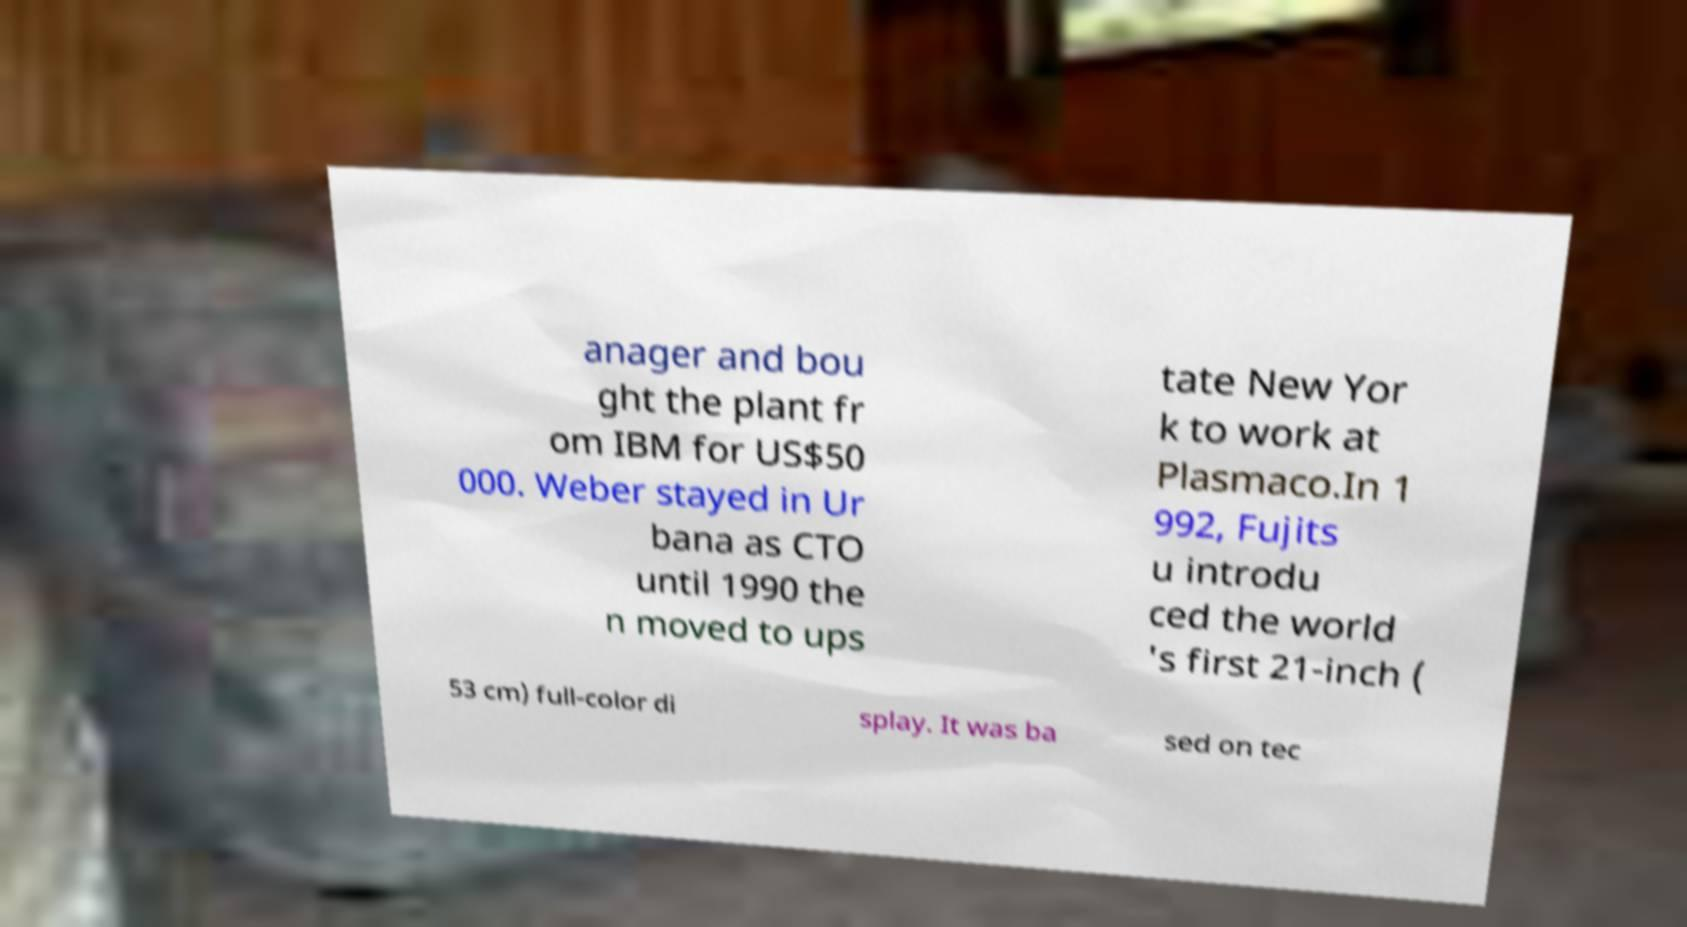Could you extract and type out the text from this image? anager and bou ght the plant fr om IBM for US$50 000. Weber stayed in Ur bana as CTO until 1990 the n moved to ups tate New Yor k to work at Plasmaco.In 1 992, Fujits u introdu ced the world 's first 21-inch ( 53 cm) full-color di splay. It was ba sed on tec 